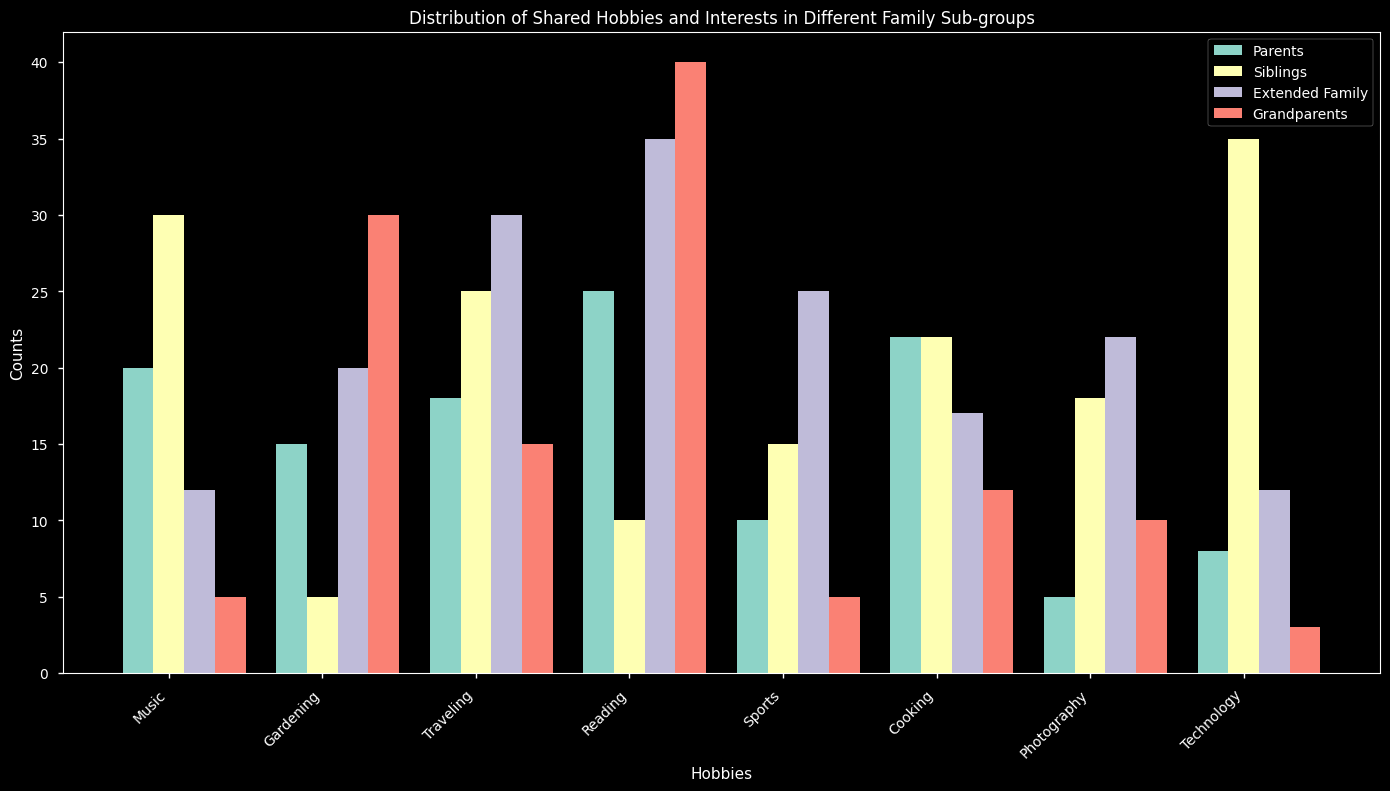What is the most popular hobby among siblings? Among the bars representing the Siblings sub-group, the tallest bar indicates the most popular hobby. The bar corresponding to "Technology" is the highest among Siblings.
Answer: Technology Which sub-group participates the least in Cooking? By comparing the heights of the bars under the Cooking category, the shortest bar indicates the least participation. The Grandparents sub-group has the shortest bar.
Answer: Grandparents What is the total number of hobbies shared by the Parents sub-group? Sum the heights of the bars for the Parents sub-group. The counts are 20 (Music) + 15 (Gardening) + 18 (Traveling) + 25 (Reading) + 10 (Sports) + 22 (Cooking) + 5 (Photography) + 8 (Technology), so the total is 123.
Answer: 123 How many more family members in the Siblings group are interested in Photography compared to Parents? Subtract the count of Photography in Parents from Siblings. Siblings have 18, and Parents have 5, so the difference is 18 - 5 = 13.
Answer: 13 Which sub-group shows the highest interest in Reading? Compare the heights of the Reading bars among all sub-groups. Grandparents have the highest bar for Reading.
Answer: Grandparents Are there any hobbies where all sub-groups have exactly equal participation? By observing the heights of the bars for each hobby, identify if there’s a hobby where all sub-groups have bars of the same height. There are no hobbies where all sub-groups have bars of the same height.
Answer: No What is the difference in the number of Cooking hobbyists between Parents and Extended Family? Subtract the count of Cooking in Extended Family from Parents. Parents have 22, and Extended Family has 17, so the difference is 22 - 17 = 5.
Answer: 5 Which sub-group shows the least interest in Music, and by how much compared to the most interested sub-group? Compare the heights of the Music bars. Grandparents show the least interest with a count of 5. Parents show the most with a count of 20. The difference is 20 - 5 = 15.
Answer: Grandparents, 15 How many total family members are interested in Technology? Sum the counts of Technology for all sub-groups. The totals are 8 (Parents) + 35 (Siblings) + 12 (Extended Family) + 3 (Grandparents), so the sum is 8 + 35 + 12 + 3 = 58.
Answer: 58 Which sub-group shows the highest interest disparity between Gardening and Reading, and what is that disparity? Calculate the absolute differences between Gardening and Reading counts for each sub-group: Parents (10), Siblings (5), Extended Family (15), Grandparents (10). The highest disparity is in Extended Family:
Answer: Extended Family, 15 